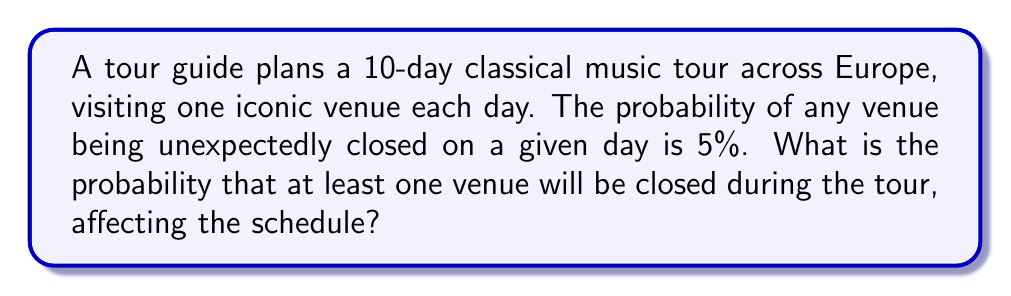Solve this math problem. Let's approach this step-by-step:

1) First, we need to find the probability that all venues will be open during the tour. This is easier than directly calculating the probability of at least one closure.

2) For a single day, the probability of a venue being open is:
   $1 - 0.05 = 0.95$ or $95\%$

3) For all 10 days to have open venues, we need this to happen independently for each day. We can calculate this using the multiplication rule of probability:

   $P(\text{all open}) = 0.95^{10}$

4) We can calculate this:
   $0.95^{10} \approx 0.5987$

5) Now, the probability of at least one venue being closed is the complement of all venues being open:

   $P(\text{at least one closed}) = 1 - P(\text{all open})$

6) Therefore:
   $P(\text{at least one closed}) = 1 - 0.5987 \approx 0.4013$

7) Converting to a percentage:
   $0.4013 \times 100\% \approx 40.13\%$
Answer: $40.13\%$ 